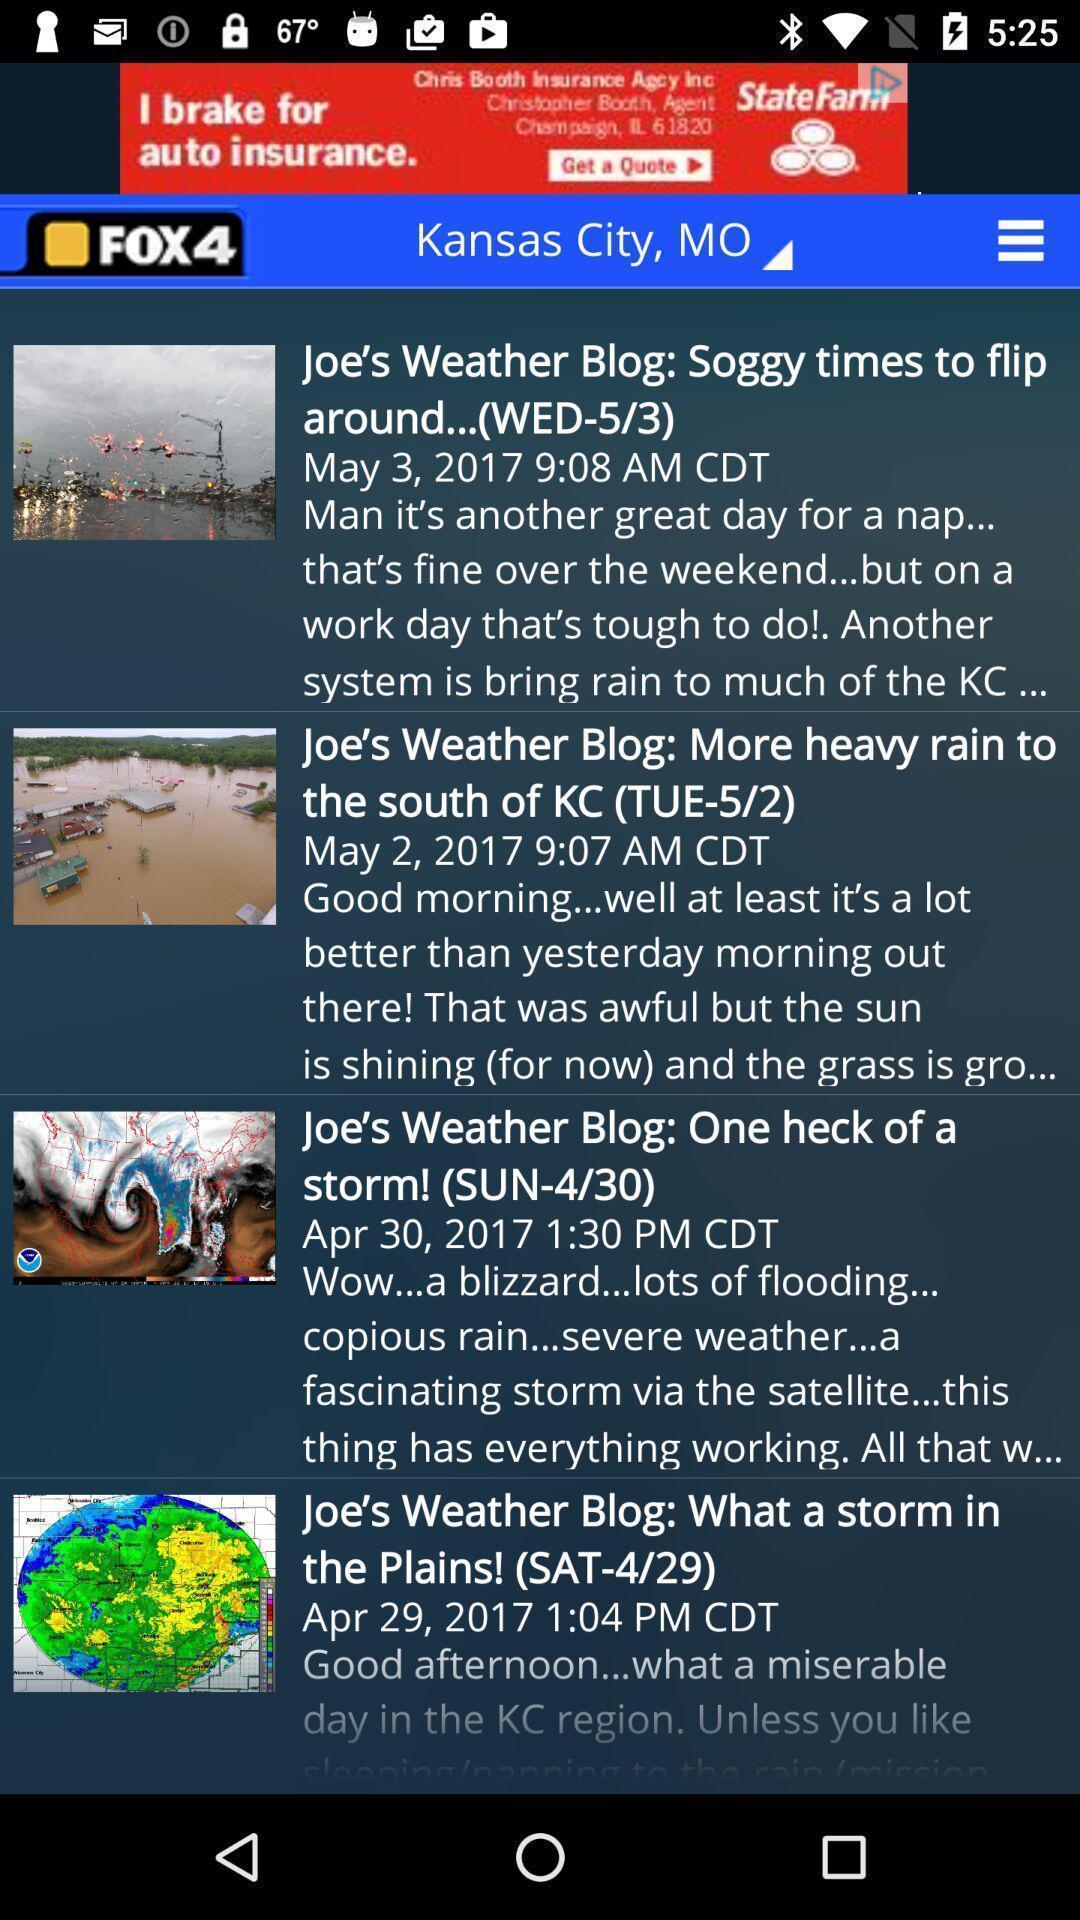Summarize the main components in this picture. Page showing information about weather. 